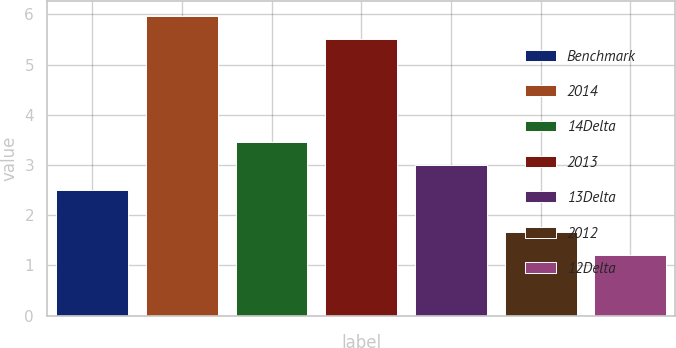<chart> <loc_0><loc_0><loc_500><loc_500><bar_chart><fcel>Benchmark<fcel>2014<fcel>14Delta<fcel>2013<fcel>13Delta<fcel>2012<fcel>12Delta<nl><fcel>2.5<fcel>5.96<fcel>3.46<fcel>5.5<fcel>3<fcel>1.66<fcel>1.2<nl></chart> 